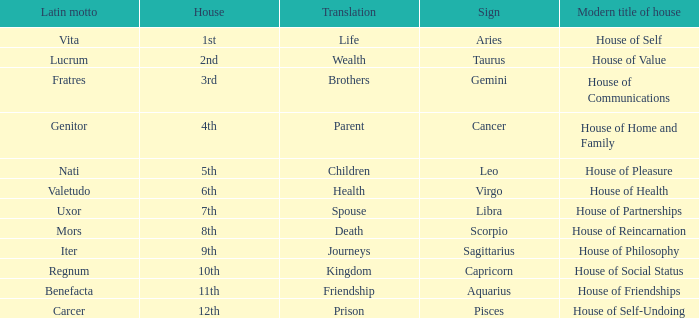What is the modern house title of the 1st house? House of Self. 